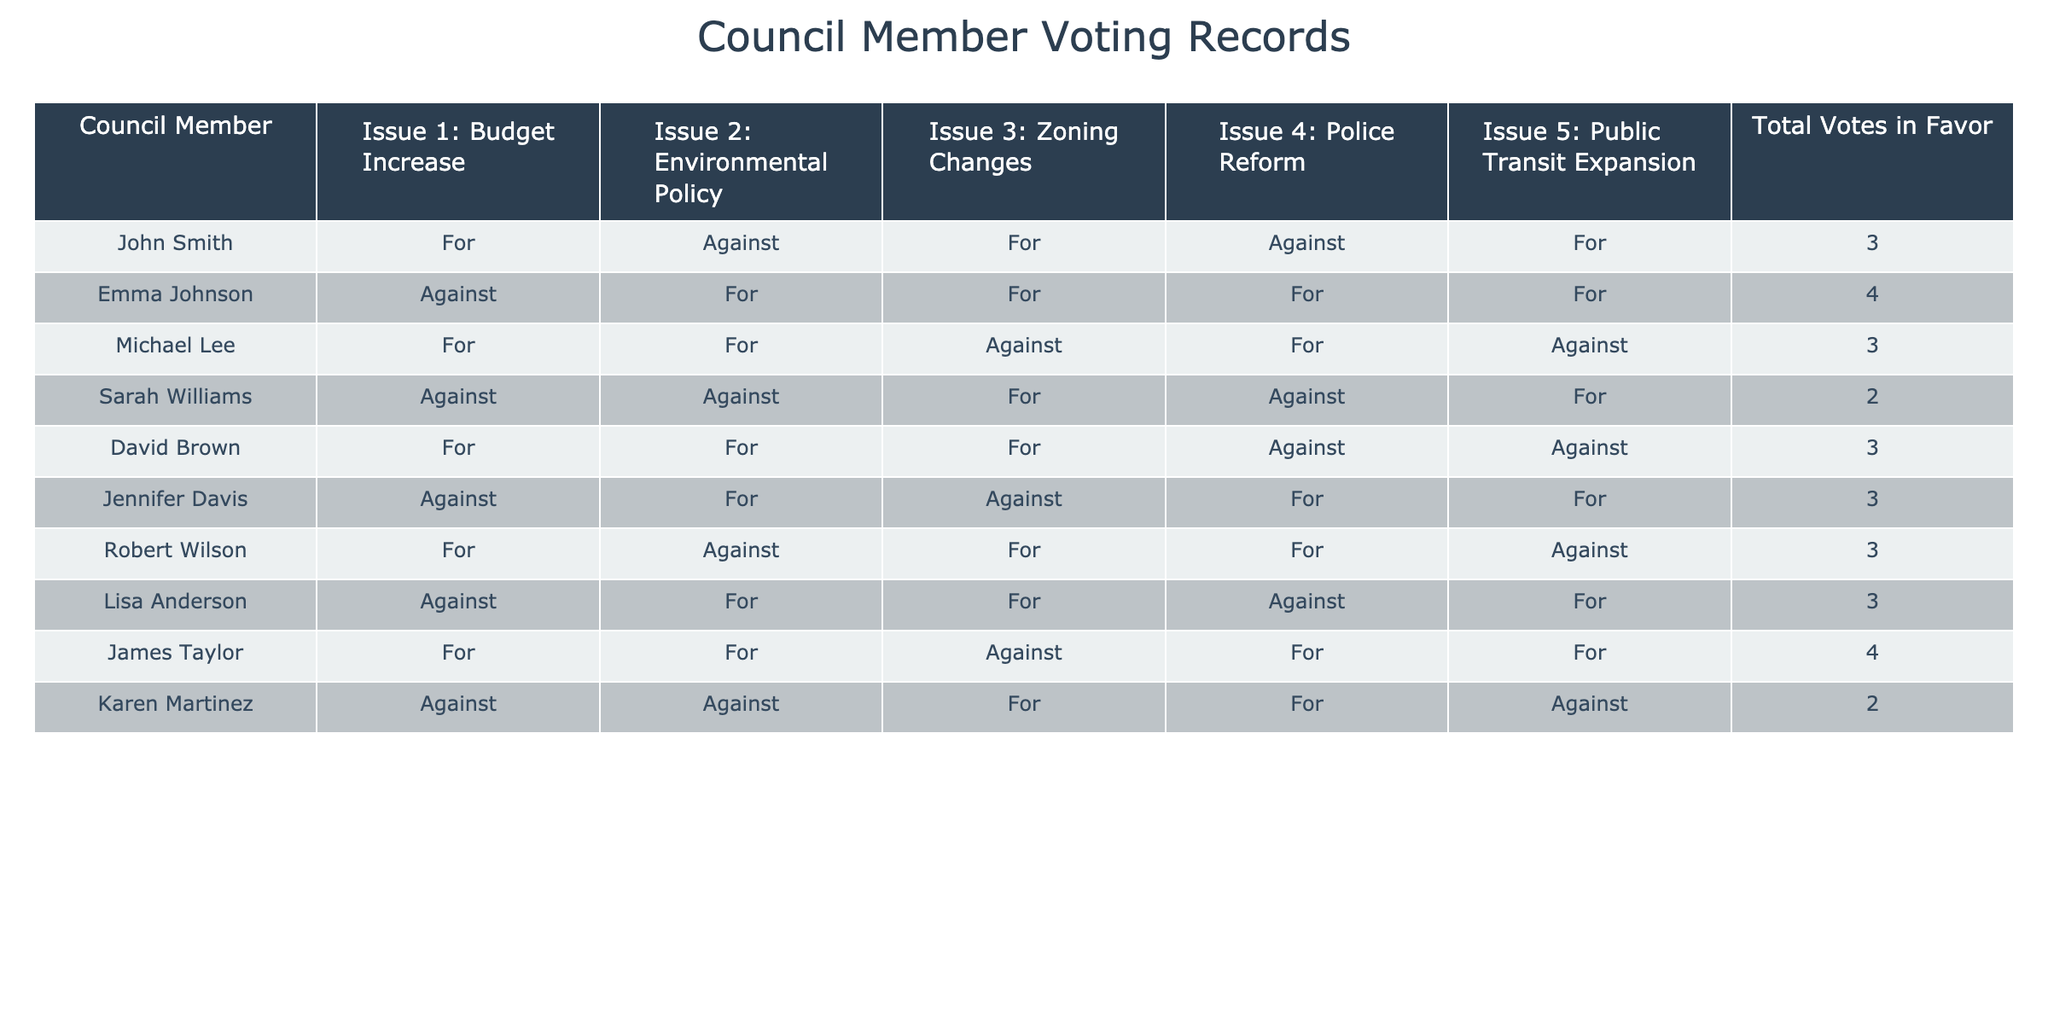What is the total number of votes in favor for John Smith? According to the table, John Smith has a total of 3 votes in favor.
Answer: 3 How many members voted against the Environmental Policy? Looking at the table, there are 4 members who voted against the Environmental Policy: John Smith, Sarah Williams, David Brown, and Karen Martinez.
Answer: 4 Who voted in favor of all five issues? By checking the table, it is clear that no council member voted in favor of all five issues. The maximum in favor is 4 votes.
Answer: No one What percentage of votes in favor did Emma Johnson receive? Emma Johnson received 4 votes in favor out of 5 issues, which translates to (4/5) * 100 = 80%.
Answer: 80% How many members voted for Police Reform but against Public Transit Expansion? By analyzing the table, Michael Lee, Robert Wilson, and Jennifer Davis voted for Police Reform and against Public Transit Expansion. This gives a total of 3 members.
Answer: 3 Which member has the least number of votes in favor? Looking through the total votes in favor column, Sarah Williams has the least with 2 votes in favor.
Answer: Sarah Williams What is the average number of votes in favor among all council members? Adding the total votes in favor (3 + 4 + 3 + 2 + 3 + 3 + 3 + 3 + 4 + 2 = 32) and dividing it by the number of members (10) gives an average of 3.2 votes in favor.
Answer: 3.2 Are there more members who voted against Zoning Changes than those who voted for it? Checking the votes, 6 members voted for Zoning Changes while only 4 voted against it. Therefore, more members voted for than against.
Answer: No Which issues had the highest agreement (most votes in favor)? By examining the table, the issues that received the most votes in favor are Environmental Policy and Public Transit Expansion, both with 6 votes in favor.
Answer: Environmental Policy and Public Transit Expansion How many members voted for at least 4 issues? Analyzing the table, 3 members voted for at least 4 issues: Emma Johnson and James Taylor (4 votes each).
Answer: 2 